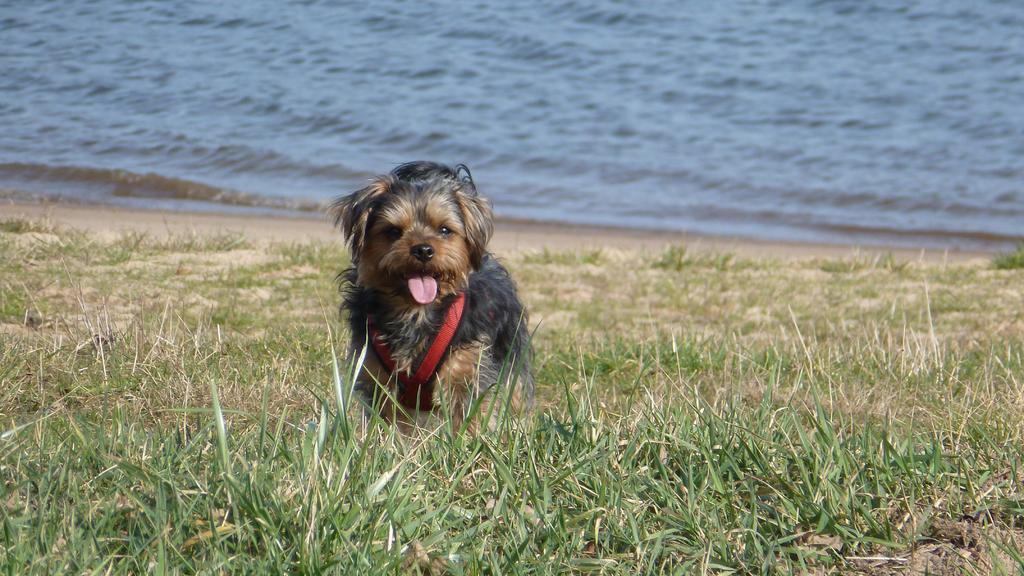What animal can be seen in the image? There is a dog in the image. Where is the dog located? The dog is on the grass. What else can be seen in the image besides the dog? There is water visible in the image. How does the dog contribute to the growth of the grass in the image? The dog does not contribute to the growth of the grass in the image; it is simply located on the grass. 